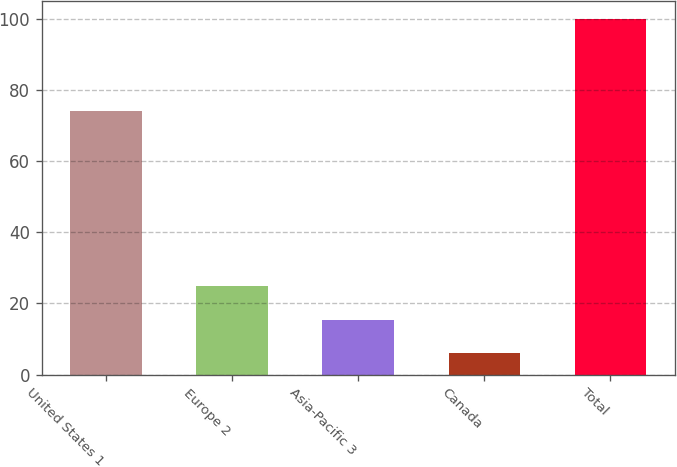<chart> <loc_0><loc_0><loc_500><loc_500><bar_chart><fcel>United States 1<fcel>Europe 2<fcel>Asia-Pacific 3<fcel>Canada<fcel>Total<nl><fcel>74<fcel>24.8<fcel>15.4<fcel>6<fcel>100<nl></chart> 